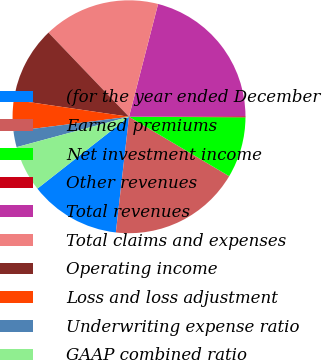Convert chart. <chart><loc_0><loc_0><loc_500><loc_500><pie_chart><fcel>(for the year ended December<fcel>Earned premiums<fcel>Net investment income<fcel>Other revenues<fcel>Total revenues<fcel>Total claims and expenses<fcel>Operating income<fcel>Loss and loss adjustment<fcel>Underwriting expense ratio<fcel>GAAP combined ratio<nl><fcel>12.61%<fcel>18.28%<fcel>8.45%<fcel>0.15%<fcel>20.91%<fcel>16.17%<fcel>10.53%<fcel>4.3%<fcel>2.22%<fcel>6.38%<nl></chart> 